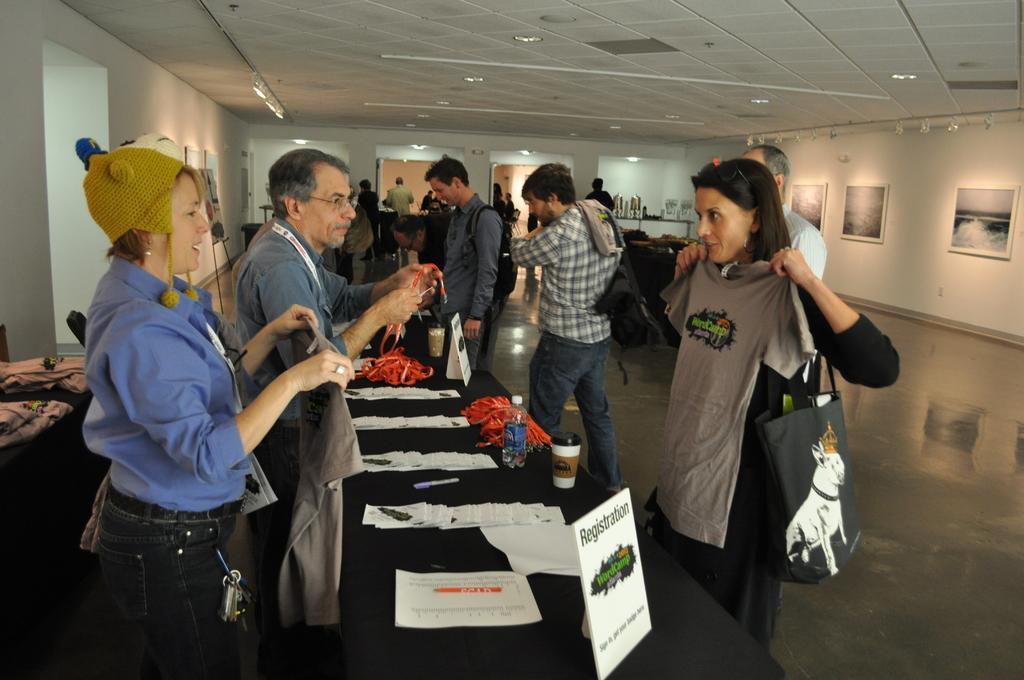Can you describe this image briefly? In this there are people standing. In the center there is a table. There are papers, boards, cups and bottles on the table. There are a few people standing beside the table. The woman to the right is holding a t-shirt and wearing a handbag. The woman to the left is holding a t-shirt in her hand. There are lights to the ceiling. To the right there is a wall. There are picture frames on the wall. In the background there are boards. 